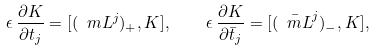<formula> <loc_0><loc_0><loc_500><loc_500>\epsilon \, \frac { \partial K } { \partial t _ { j } } = [ ( \ m L ^ { j } ) _ { + } , K ] , \quad \epsilon \, \frac { \partial K } { \partial \bar { t } _ { j } } = [ ( \bar { \ m L } ^ { j } ) _ { - } , K ] ,</formula> 